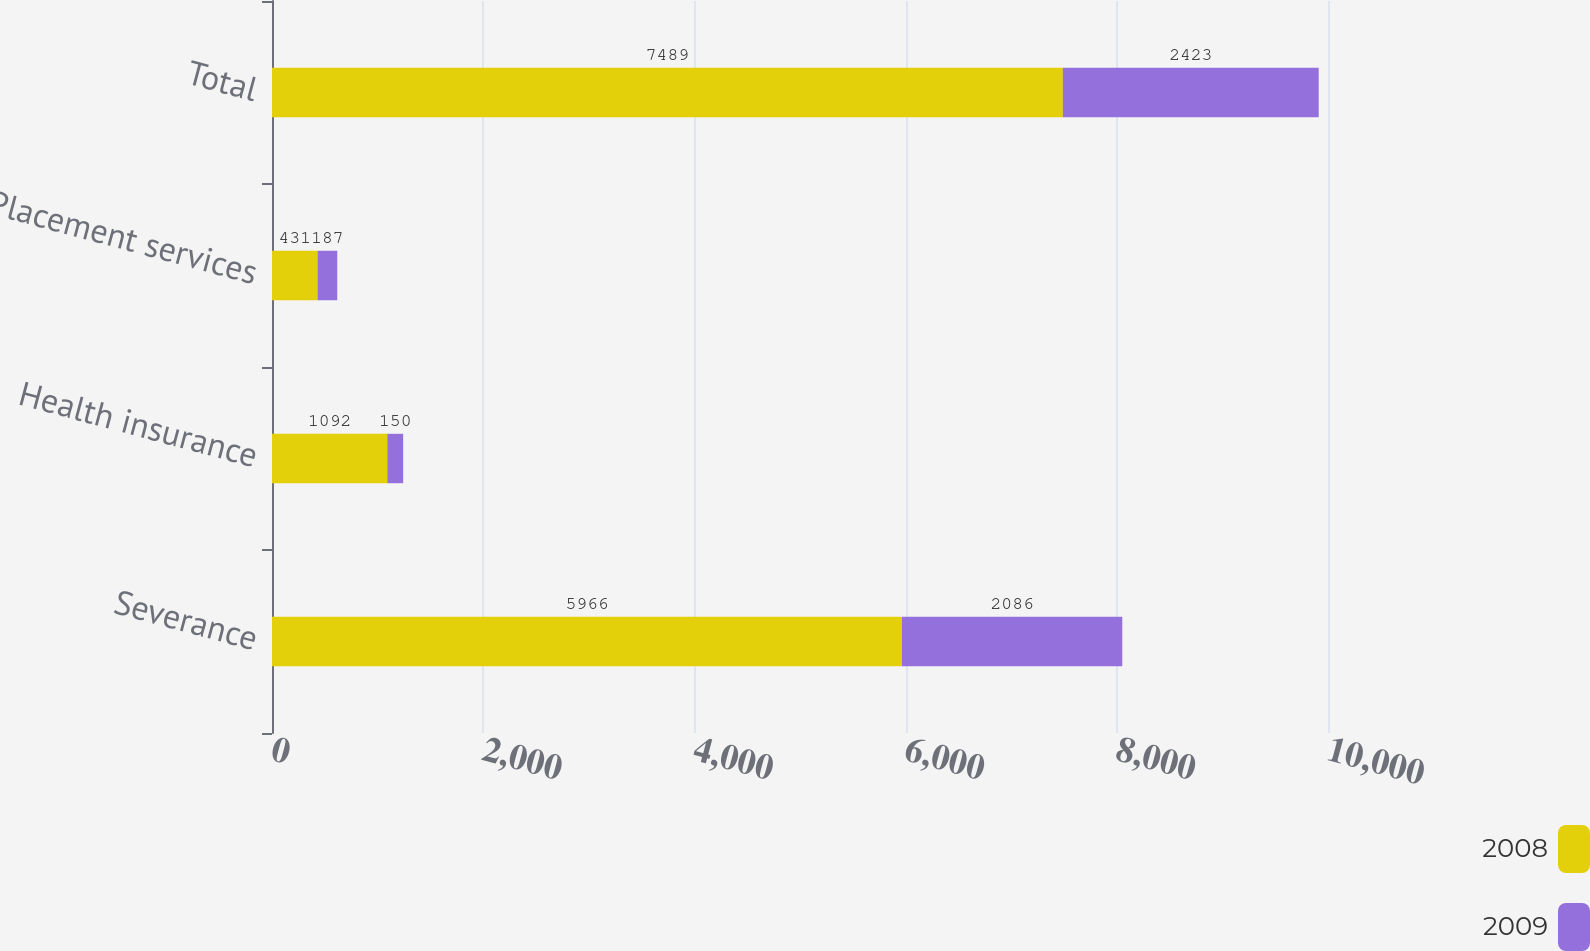Convert chart. <chart><loc_0><loc_0><loc_500><loc_500><stacked_bar_chart><ecel><fcel>Severance<fcel>Health insurance<fcel>Placement services<fcel>Total<nl><fcel>2008<fcel>5966<fcel>1092<fcel>431<fcel>7489<nl><fcel>2009<fcel>2086<fcel>150<fcel>187<fcel>2423<nl></chart> 